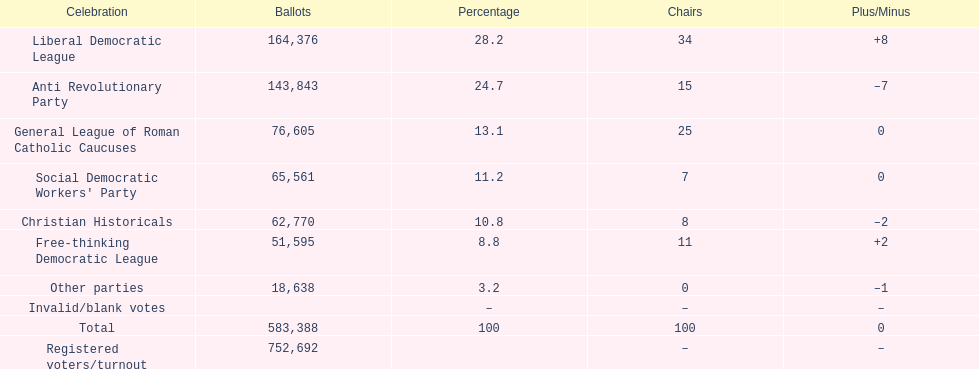After the election, how many seats did the liberal democratic league win? 34. 